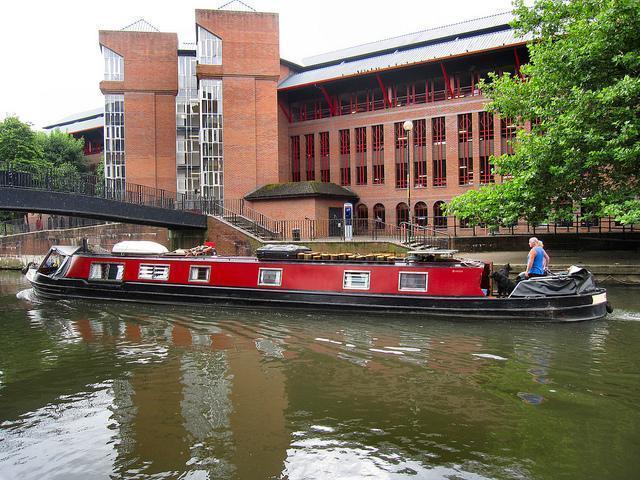How is this vessel being propelled?
Indicate the correct choice and explain in the format: 'Answer: answer
Rationale: rationale.'
Options: Tugged, motor, wind, paddle. Answer: motor.
Rationale: There is a motor shown at the back of the boat. 